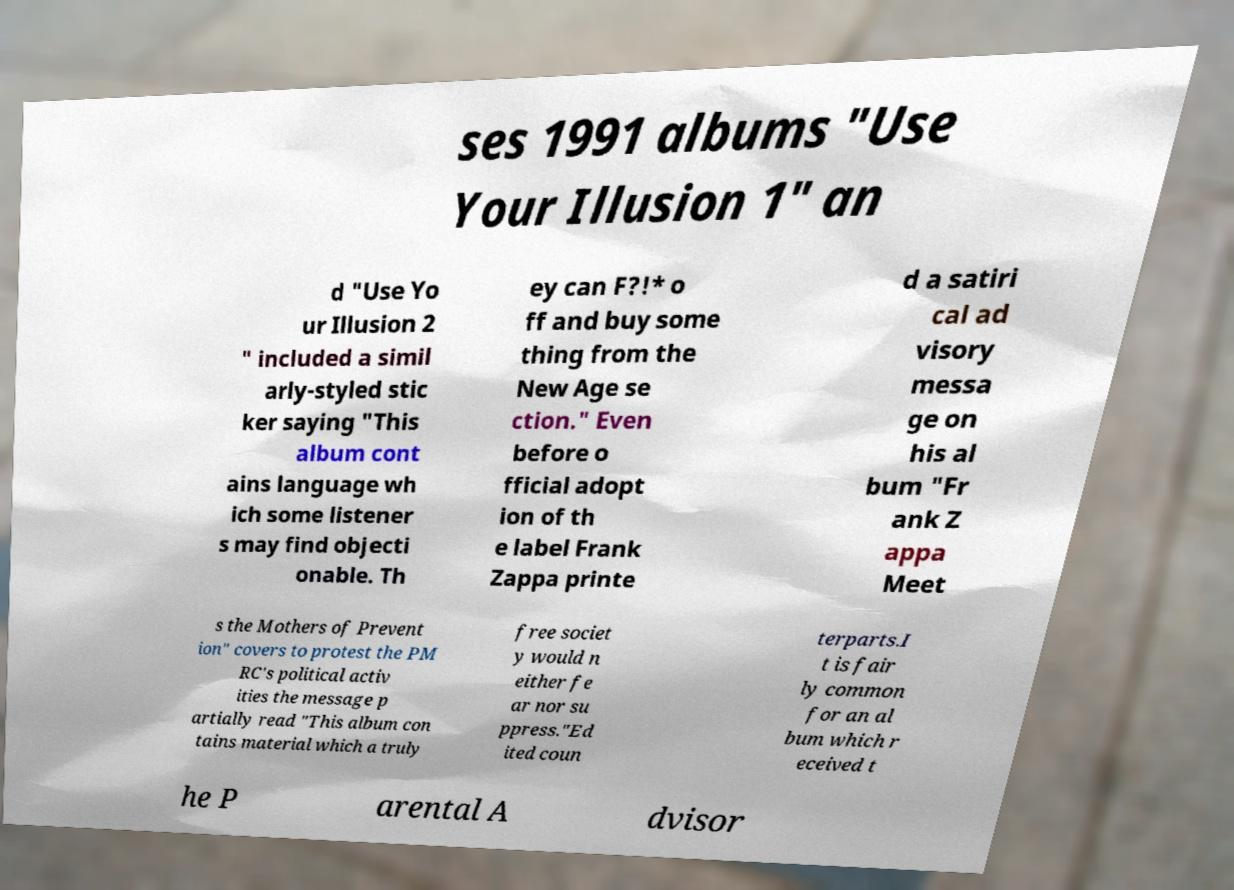Can you read and provide the text displayed in the image?This photo seems to have some interesting text. Can you extract and type it out for me? ses 1991 albums "Use Your Illusion 1" an d "Use Yo ur Illusion 2 " included a simil arly-styled stic ker saying "This album cont ains language wh ich some listener s may find objecti onable. Th ey can F?!* o ff and buy some thing from the New Age se ction." Even before o fficial adopt ion of th e label Frank Zappa printe d a satiri cal ad visory messa ge on his al bum "Fr ank Z appa Meet s the Mothers of Prevent ion" covers to protest the PM RC's political activ ities the message p artially read "This album con tains material which a truly free societ y would n either fe ar nor su ppress."Ed ited coun terparts.I t is fair ly common for an al bum which r eceived t he P arental A dvisor 